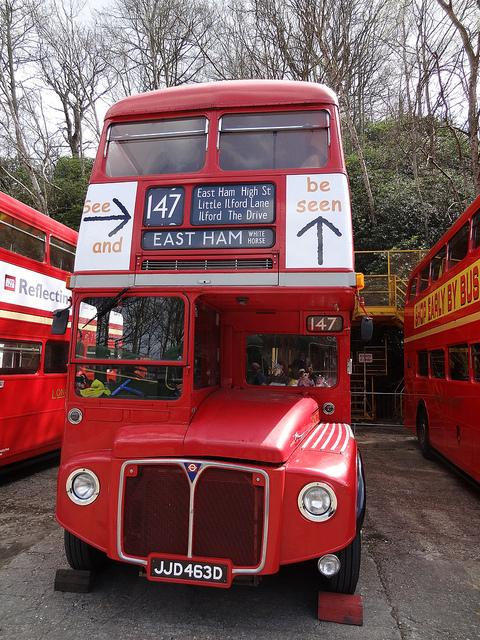What do the items in front of the tires here prevent? Please explain your reasoning. rolling. The bricks are there as a stopper for the tires in case the bus tries to roll forward. 